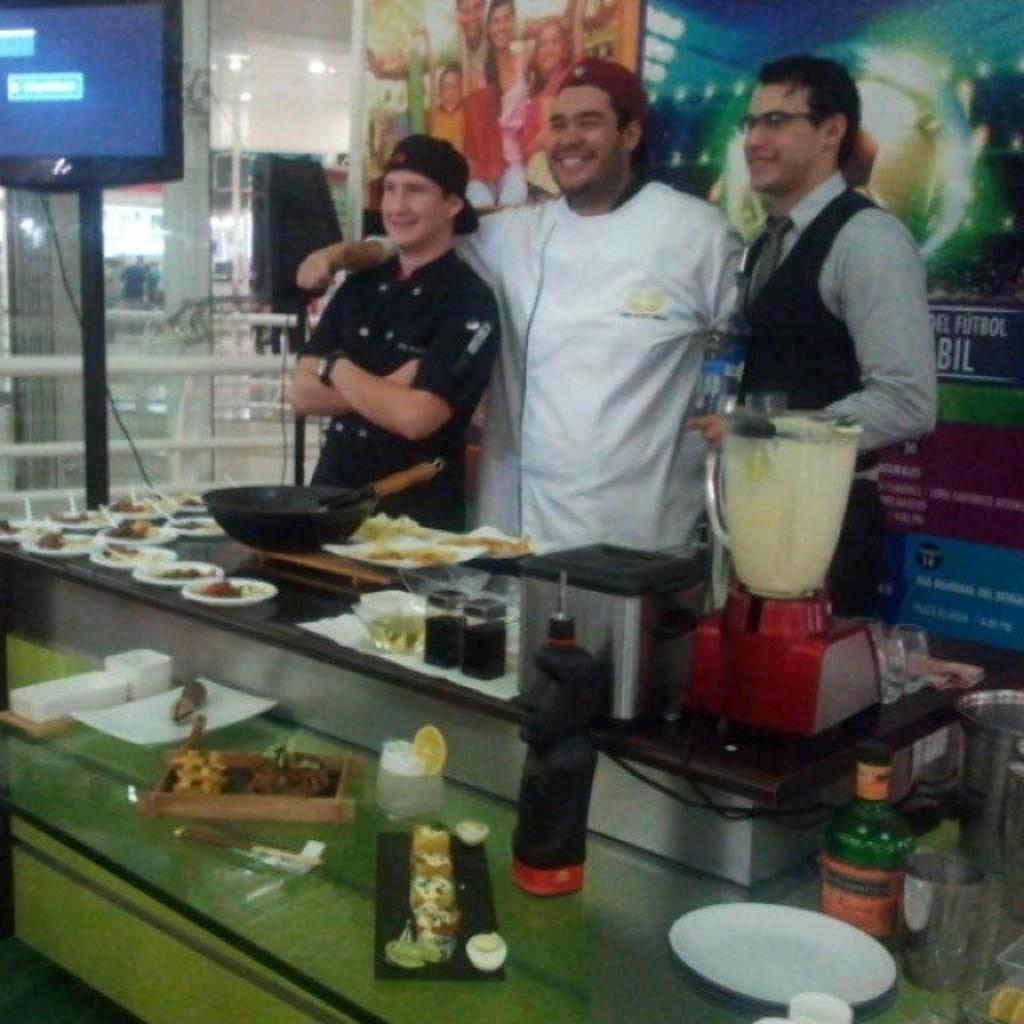How many people are present in the image? There are three persons standing in the image. What can be seen in front of the persons? There are eatables and other objects in front of the persons. Where is the television located in the image? The television is in the left top corner of the image. How many chickens are visible in the image? There are no chickens present in the image. What type of pancake is being served to the persons in the image? There is no pancake visible in the image. 